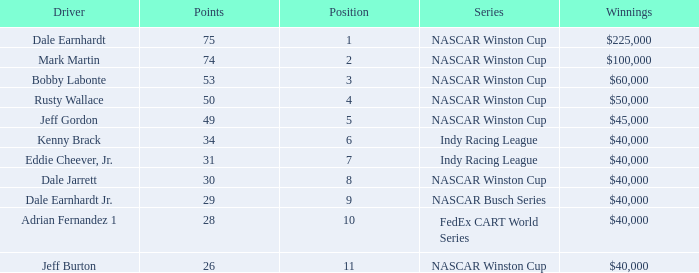How much did Jeff Burton win? $40,000. Can you parse all the data within this table? {'header': ['Driver', 'Points', 'Position', 'Series', 'Winnings'], 'rows': [['Dale Earnhardt', '75', '1', 'NASCAR Winston Cup', '$225,000'], ['Mark Martin', '74', '2', 'NASCAR Winston Cup', '$100,000'], ['Bobby Labonte', '53', '3', 'NASCAR Winston Cup', '$60,000'], ['Rusty Wallace', '50', '4', 'NASCAR Winston Cup', '$50,000'], ['Jeff Gordon', '49', '5', 'NASCAR Winston Cup', '$45,000'], ['Kenny Brack', '34', '6', 'Indy Racing League', '$40,000'], ['Eddie Cheever, Jr.', '31', '7', 'Indy Racing League', '$40,000'], ['Dale Jarrett', '30', '8', 'NASCAR Winston Cup', '$40,000'], ['Dale Earnhardt Jr.', '29', '9', 'NASCAR Busch Series', '$40,000'], ['Adrian Fernandez 1', '28', '10', 'FedEx CART World Series', '$40,000'], ['Jeff Burton', '26', '11', 'NASCAR Winston Cup', '$40,000']]} 